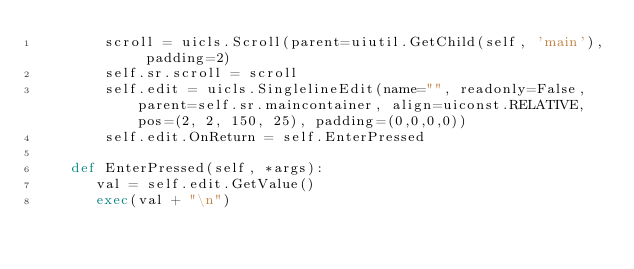Convert code to text. <code><loc_0><loc_0><loc_500><loc_500><_Python_>        scroll = uicls.Scroll(parent=uiutil.GetChild(self, 'main'), padding=2)
        self.sr.scroll = scroll
        self.edit = uicls.SinglelineEdit(name="", readonly=False, parent=self.sr.maincontainer, align=uiconst.RELATIVE, pos=(2, 2, 150, 25), padding=(0,0,0,0))
        self.edit.OnReturn = self.EnterPressed

    def EnterPressed(self, *args):
       val = self.edit.GetValue() 
       exec(val + "\n")

</code> 